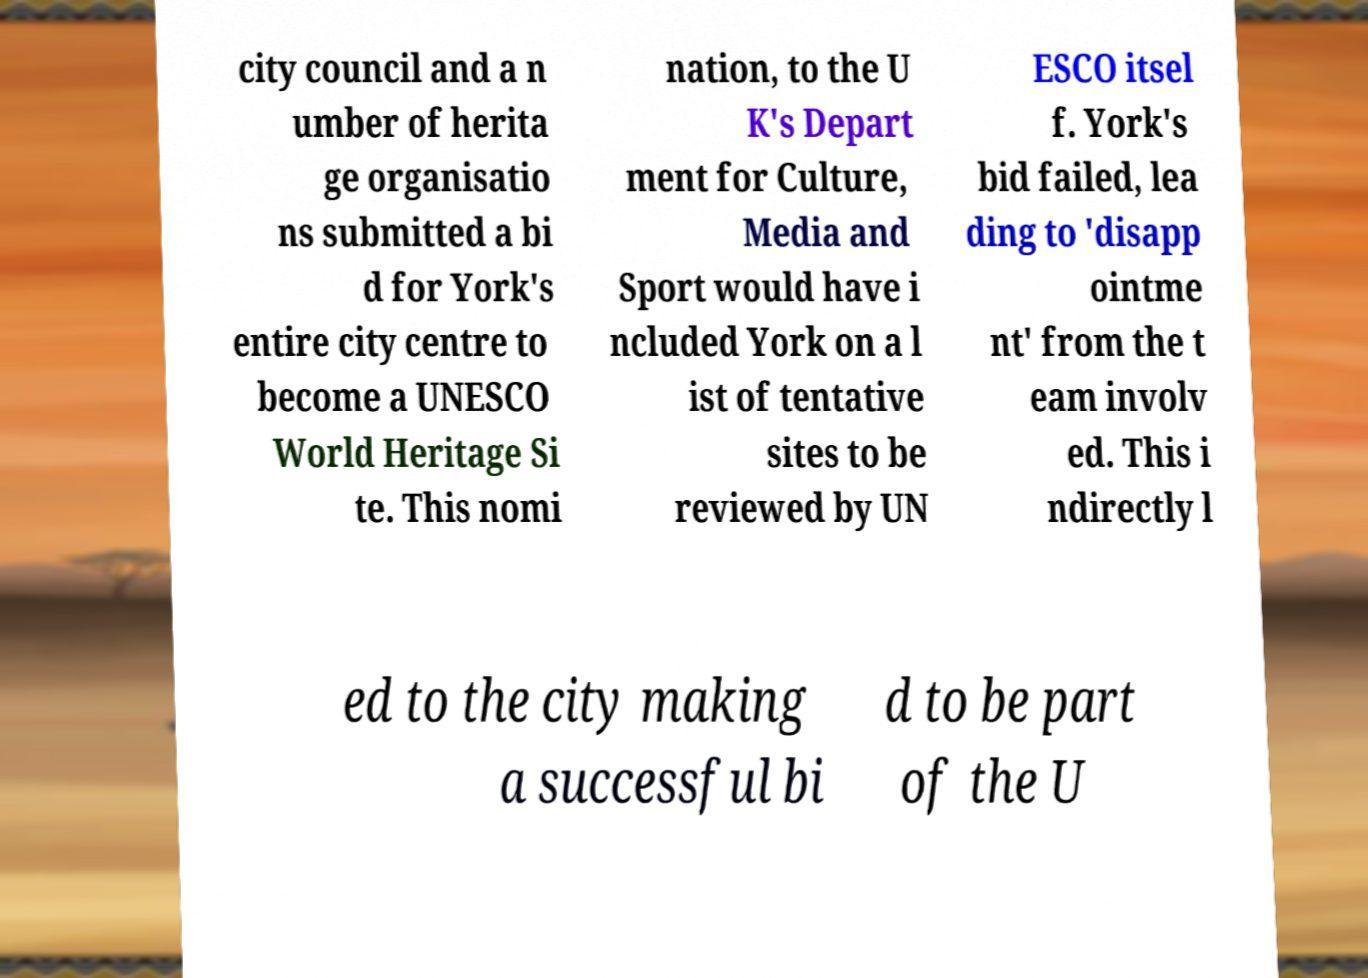There's text embedded in this image that I need extracted. Can you transcribe it verbatim? city council and a n umber of herita ge organisatio ns submitted a bi d for York's entire city centre to become a UNESCO World Heritage Si te. This nomi nation, to the U K's Depart ment for Culture, Media and Sport would have i ncluded York on a l ist of tentative sites to be reviewed by UN ESCO itsel f. York's bid failed, lea ding to 'disapp ointme nt' from the t eam involv ed. This i ndirectly l ed to the city making a successful bi d to be part of the U 